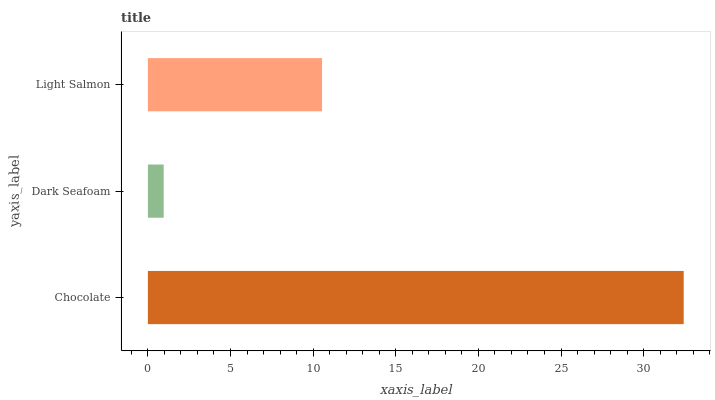Is Dark Seafoam the minimum?
Answer yes or no. Yes. Is Chocolate the maximum?
Answer yes or no. Yes. Is Light Salmon the minimum?
Answer yes or no. No. Is Light Salmon the maximum?
Answer yes or no. No. Is Light Salmon greater than Dark Seafoam?
Answer yes or no. Yes. Is Dark Seafoam less than Light Salmon?
Answer yes or no. Yes. Is Dark Seafoam greater than Light Salmon?
Answer yes or no. No. Is Light Salmon less than Dark Seafoam?
Answer yes or no. No. Is Light Salmon the high median?
Answer yes or no. Yes. Is Light Salmon the low median?
Answer yes or no. Yes. Is Dark Seafoam the high median?
Answer yes or no. No. Is Dark Seafoam the low median?
Answer yes or no. No. 